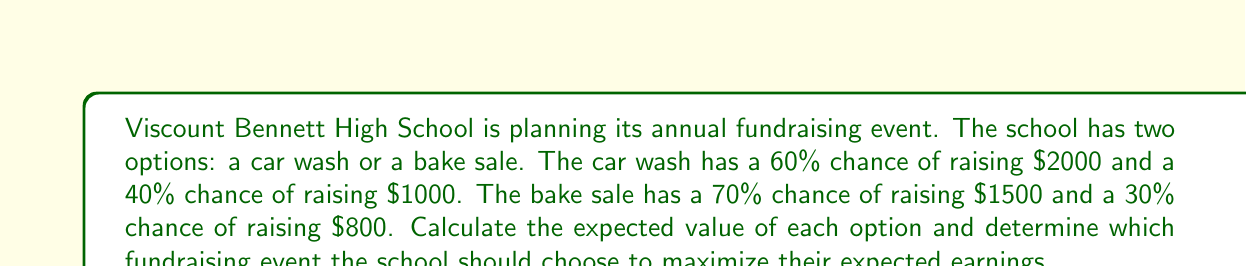Show me your answer to this math problem. Let's approach this problem step-by-step using the concept of expected value.

1. Calculate the expected value of the car wash:
   
   The expected value is the sum of each possible outcome multiplied by its probability.

   $$E(\text{Car Wash}) = (0.60 \times \$2000) + (0.40 \times \$1000)$$
   $$E(\text{Car Wash}) = \$1200 + \$400 = \$1600$$

2. Calculate the expected value of the bake sale:
   
   $$E(\text{Bake Sale}) = (0.70 \times \$1500) + (0.30 \times \$800)$$
   $$E(\text{Bake Sale}) = \$1050 + \$240 = \$1290$$

3. Compare the expected values:
   
   The car wash has an expected value of $1600, while the bake sale has an expected value of $1290.

4. Make a decision:
   
   Since the car wash has a higher expected value, it is the better choice to maximize expected earnings.
Answer: The school should choose the car wash, which has an expected value of $1600, compared to the bake sale's expected value of $1290. 